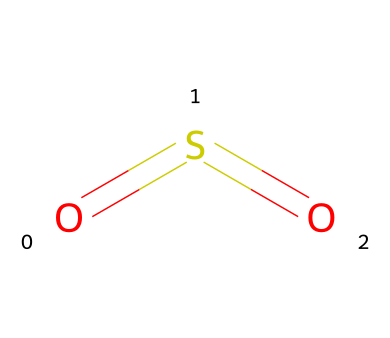What is the name of this chemical? The structural representation shows sulfur (S) bonded to two oxygen (O) atoms, which is characteristic of sulfur dioxide.
Answer: sulfur dioxide How many oxygen atoms are present in the chemical structure? Upon examining the SMILES representation, we see that there are two oxygen atoms indicated in the structure.
Answer: two What type of bonding is present in sulfur dioxide? The structure shows double bonds between sulfur and each oxygen atom, indicating that sulfur dioxide exhibits covalent bonding.
Answer: covalent What is the total number of atoms in the molecule? The chemical consists of one sulfur atom and two oxygen atoms, making a total of three atoms in the molecule.
Answer: three Is sulfur dioxide a pollutant? Yes, sulfur dioxide is known to be a pollutant, primarily produced from industrial processes, which contributes to air quality issues.
Answer: yes What characteristic property does sulfur dioxide have that makes it relevant for art? Sulfur dioxide can be used in various artistic processes, such as in the creation of sulfur-based pigments which can add color to artworks.
Answer: pigments 